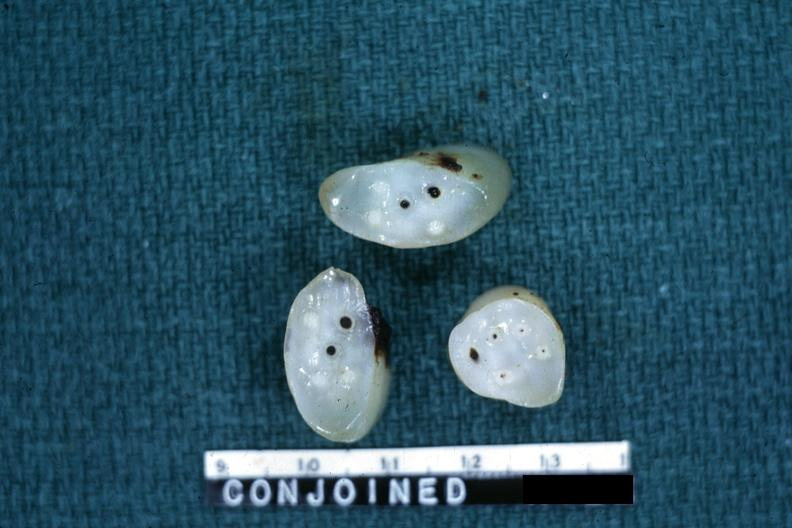does this image show cross sections showing apparently four arteries and two veins?
Answer the question using a single word or phrase. Yes 